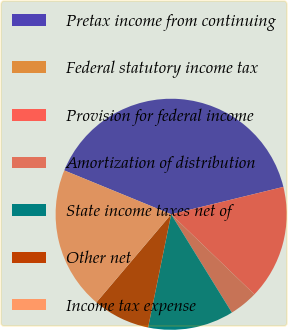Convert chart. <chart><loc_0><loc_0><loc_500><loc_500><pie_chart><fcel>Pretax income from continuing<fcel>Federal statutory income tax<fcel>Provision for federal income<fcel>Amortization of distribution<fcel>State income taxes net of<fcel>Other net<fcel>Income tax expense<nl><fcel>39.99%<fcel>0.0%<fcel>16.0%<fcel>4.0%<fcel>12.0%<fcel>8.0%<fcel>20.0%<nl></chart> 